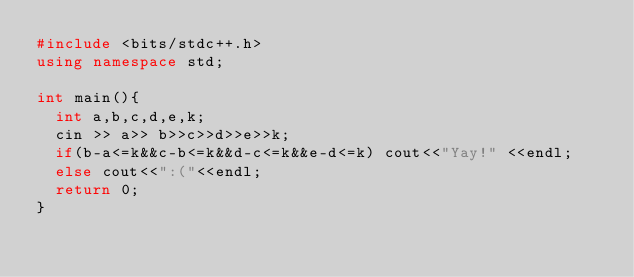Convert code to text. <code><loc_0><loc_0><loc_500><loc_500><_C++_>#include <bits/stdc++.h>
using namespace std;

int main(){
  int a,b,c,d,e,k;
  cin >> a>> b>>c>>d>>e>>k;
  if(b-a<=k&&c-b<=k&&d-c<=k&&e-d<=k) cout<<"Yay!" <<endl;
  else cout<<":("<<endl;
  return 0;
}</code> 